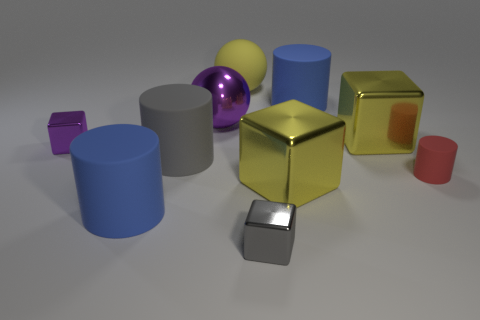Can you compare the textures of the objects and suggest what materials they might represent? The objects display a variety of textures that suggest different materials. The golden cube, for instance, has a reflective surface with slight imperfections that could resemble polished metal or gold. The matte finish of the purple cube might indicate a plastic or painted wood material. These textural cues can provide insights into their potential tactile qualities and contribute to the realism of the scene. 